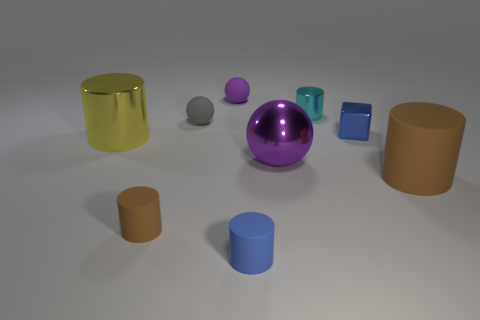Subtract all brown balls. How many brown cylinders are left? 2 Subtract 1 cylinders. How many cylinders are left? 4 Subtract all blue cylinders. How many cylinders are left? 4 Subtract all rubber spheres. How many spheres are left? 1 Subtract all blue cylinders. Subtract all blue cubes. How many cylinders are left? 4 Subtract all cylinders. How many objects are left? 4 Add 3 big shiny spheres. How many big shiny spheres are left? 4 Add 7 big purple objects. How many big purple objects exist? 8 Subtract 0 cyan cubes. How many objects are left? 9 Subtract all yellow balls. Subtract all small gray balls. How many objects are left? 8 